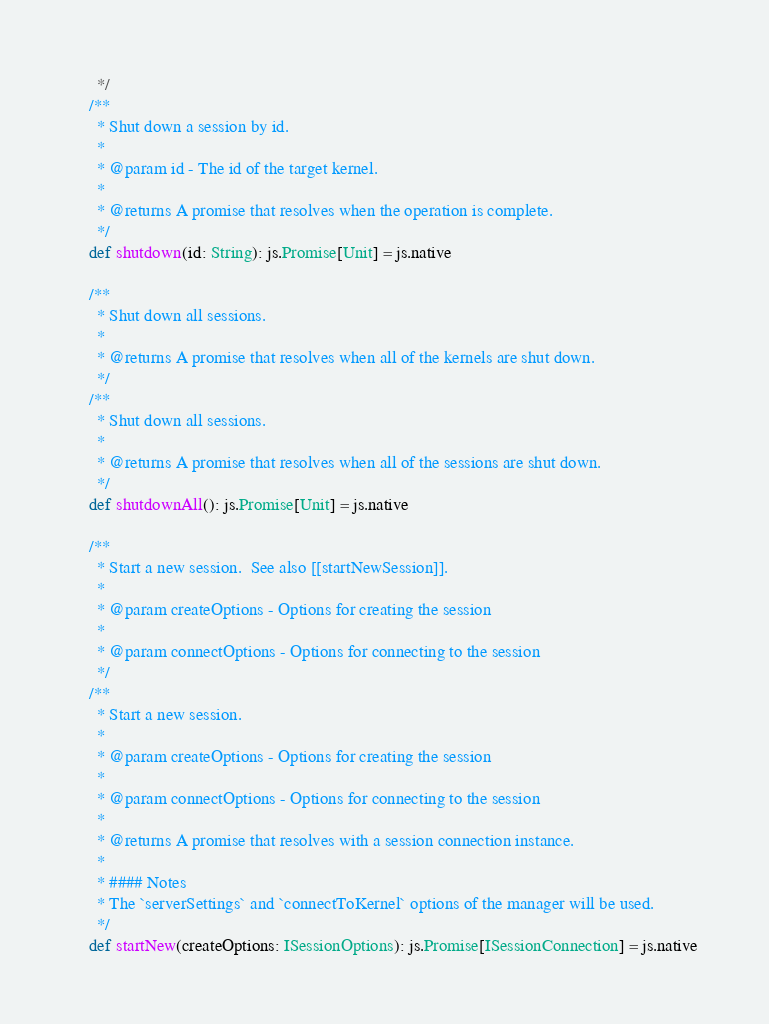<code> <loc_0><loc_0><loc_500><loc_500><_Scala_>      */
    /**
      * Shut down a session by id.
      *
      * @param id - The id of the target kernel.
      *
      * @returns A promise that resolves when the operation is complete.
      */
    def shutdown(id: String): js.Promise[Unit] = js.native
    
    /**
      * Shut down all sessions.
      *
      * @returns A promise that resolves when all of the kernels are shut down.
      */
    /**
      * Shut down all sessions.
      *
      * @returns A promise that resolves when all of the sessions are shut down.
      */
    def shutdownAll(): js.Promise[Unit] = js.native
    
    /**
      * Start a new session.  See also [[startNewSession]].
      *
      * @param createOptions - Options for creating the session
      *
      * @param connectOptions - Options for connecting to the session
      */
    /**
      * Start a new session.
      *
      * @param createOptions - Options for creating the session
      *
      * @param connectOptions - Options for connecting to the session
      *
      * @returns A promise that resolves with a session connection instance.
      *
      * #### Notes
      * The `serverSettings` and `connectToKernel` options of the manager will be used.
      */
    def startNew(createOptions: ISessionOptions): js.Promise[ISessionConnection] = js.native</code> 